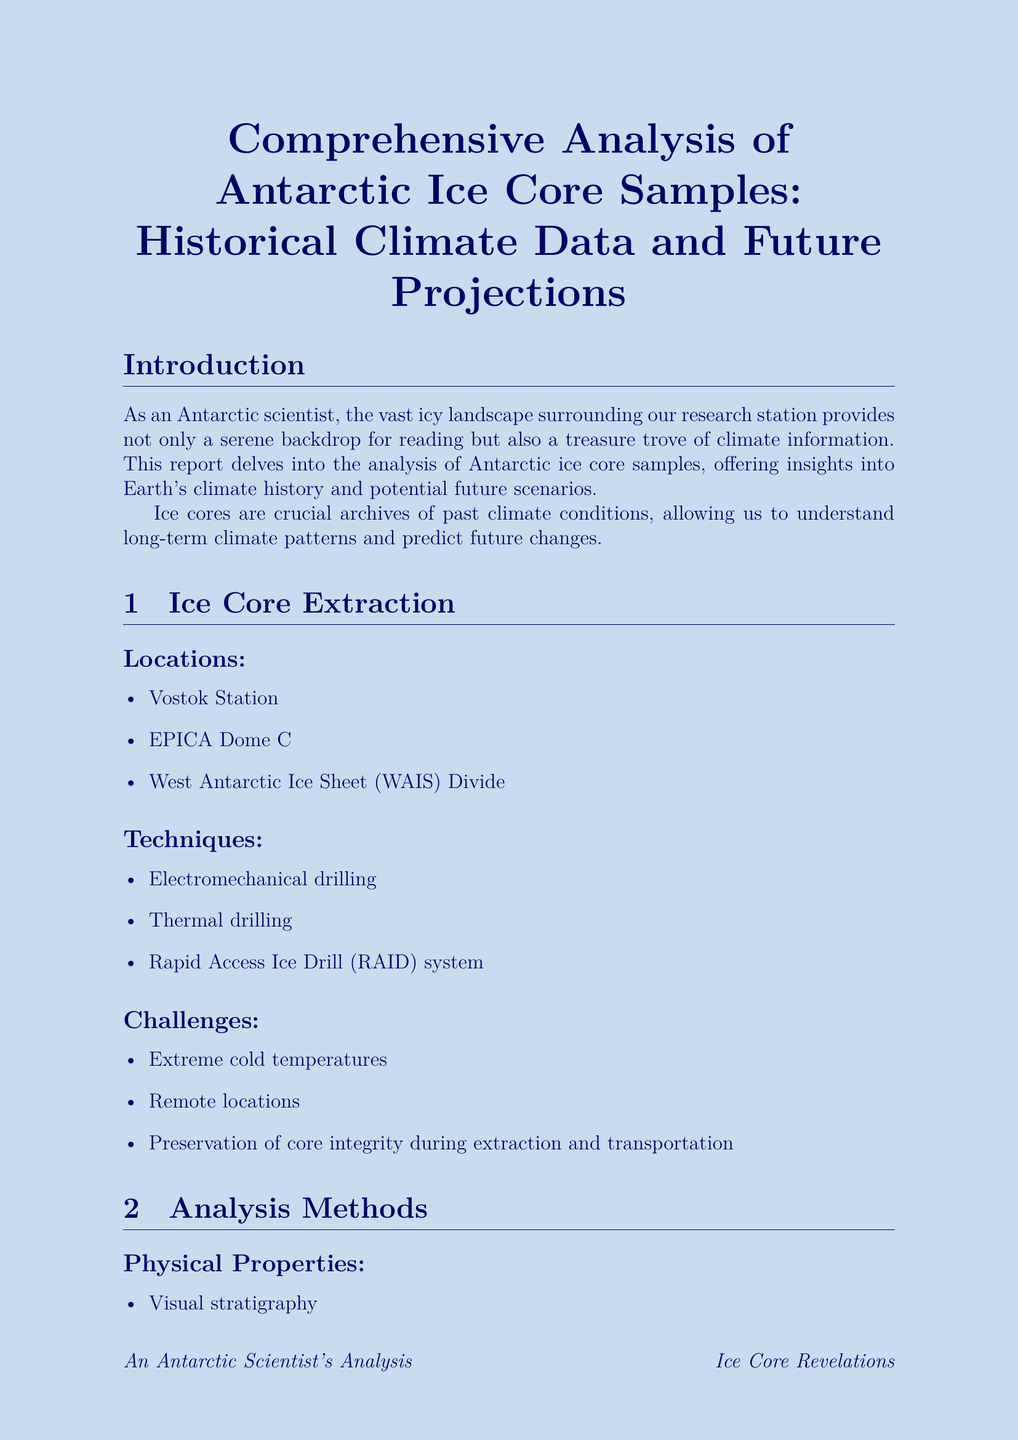what are the ice core extraction locations? The document lists specific locations where ice core samples are extracted, including "Vostok Station," "EPICA Dome C," and "West Antarctic Ice Sheet (WAIS) Divide."
Answer: Vostok Station, EPICA Dome C, West Antarctic Ice Sheet (WAIS) Divide what techniques are used for ice core extraction? The techniques mentioned in the document include "Electromechanical drilling," "Thermal drilling," and "Rapid Access Ice Drill (RAID) system."
Answer: Electromechanical drilling, Thermal drilling, Rapid Access Ice Drill (RAID) system what was the temperature difference during the last glacial maximum? According to the document, temperatures during the last glacial maximum were about "8°C colder than present."
Answer: 8°C colder than present what are future projected temperature increases by 2100? The document states the projected temperature increase ranges from "1.5°C to 4°C by 2100, depending on the scenario."
Answer: 1.5°C to 4°C by 2100 what are the three climate models mentioned in the report? The document names three climate models: "Community Earth System Model (CESM)," "Hadley Centre Coupled Model version 3 (HadCM3)," and "Max Planck Institute Earth System Model (MPI-ESM)."
Answer: Community Earth System Model (CESM), Hadley Centre Coupled Model version 3 (HadCM3), Max Planck Institute Earth System Model (MPI-ESM) which period is referred to as the Holocene Climatic Optimum? The document defines the Holocene Climatic Optimum as a "warmer period between 9,000 and 5,000 years ago."
Answer: warmer period between 9,000 and 5,000 years ago what implications does ice core data have for Antarctic ecosystems? The document lists several implications, including "shifts in penguin breeding grounds" and "changes in krill populations."
Answer: shifts in penguin breeding grounds, changes in krill populations what is a stated future research direction in the report? The document mentions the "development of new high-resolution drilling techniques" as a future research direction.
Answer: development of new high-resolution drilling techniques 